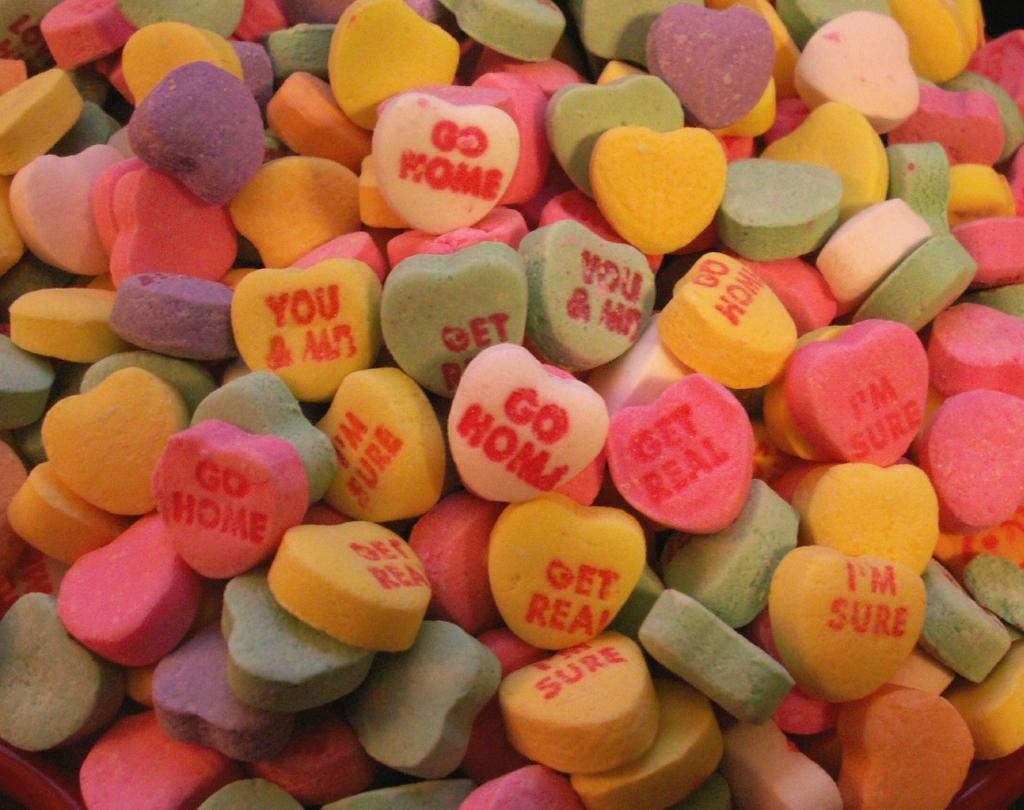Describe this image in one or two sentences. In this image, I can see colorful heart shaped candy´s. I can see the letters on few candy´s. 